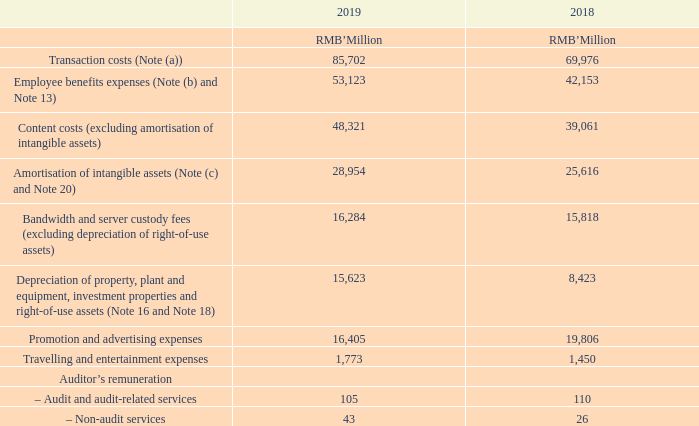8 EXPENSES BY NATURE
Note: (a) Transaction costs primarily consist of bank handling fees, channel and distribution costs.
(b) During the year ended 31 December 2019, the Group incurred expenses for the purpose of research and development of approximately RMB30,387 million (2018: RMB22,936 million), which comprised employee benefits expenses of approximately RMB24,478 million (2018: RMB19,088 million).
During the year ended 31 December 2019, employee benefits expenses included the share-based compensation expenses of approximately RMB10,500 million (2018: RMB7,900 million).
No significant development expenses had been capitalised for the years ended 31 December 2019 and 2018.
(c) Included the amortisation charges of intangible assets mainly in respect of media contents.
During the year ended 31 December 2019, amortisation of intangible assets included the amortisation of intangible assets resulting from business combinations of approximately RMB1,051 million (2018: RMB524 million).
How much did the amortisation of intangible assets resulting from business combinations for year ended 31 December 2019 amount to? Rmb1,051 million. How much was the share-based compensation expenses during the year ended 31 December 2019? Rmb10,500 million. What did the transaction costs primarily consist of? Bank handling fees, channel and distribution costs. How much is the change in transaction costs from 2018 to 2019?
Answer scale should be: million. 85,702-69,976
Answer: 15726. How much is the change in Employee benefits expenses from 2018 to 2019?
Answer scale should be: million. 53,123-42,153
Answer: 10970. How much is the change in Promotion and advertising expenses from 2018 to 2019?
Answer scale should be: million. 16,405-19,806
Answer: -3401. 